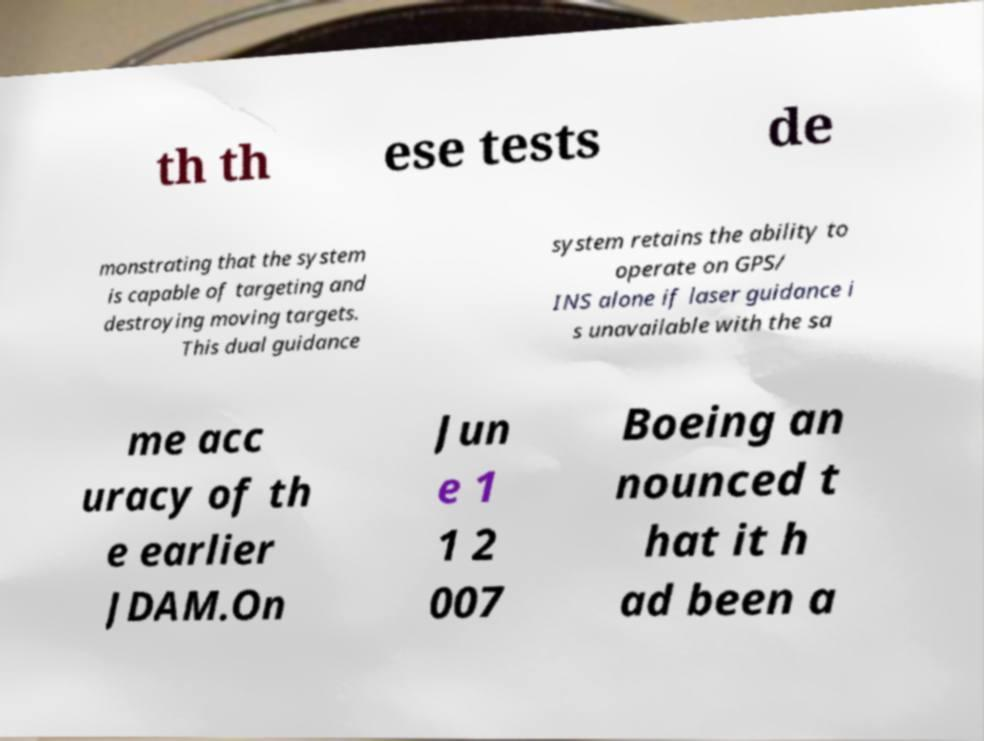There's text embedded in this image that I need extracted. Can you transcribe it verbatim? th th ese tests de monstrating that the system is capable of targeting and destroying moving targets. This dual guidance system retains the ability to operate on GPS/ INS alone if laser guidance i s unavailable with the sa me acc uracy of th e earlier JDAM.On Jun e 1 1 2 007 Boeing an nounced t hat it h ad been a 